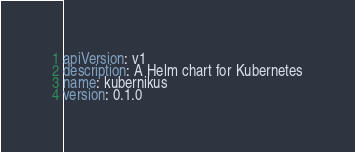Convert code to text. <code><loc_0><loc_0><loc_500><loc_500><_YAML_>apiVersion: v1
description: A Helm chart for Kubernetes
name: kubernikus
version: 0.1.0
</code> 